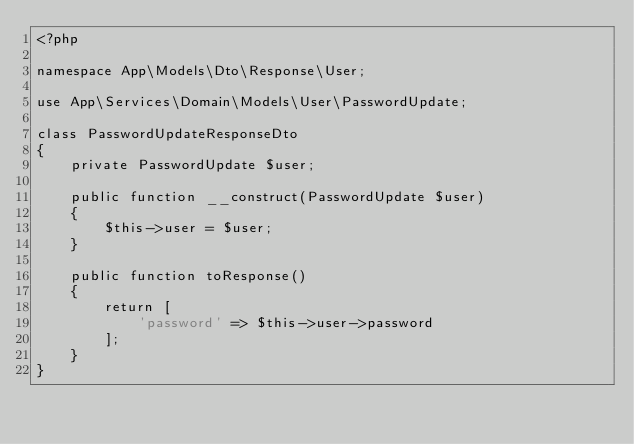<code> <loc_0><loc_0><loc_500><loc_500><_PHP_><?php

namespace App\Models\Dto\Response\User;

use App\Services\Domain\Models\User\PasswordUpdate;

class PasswordUpdateResponseDto
{
    private PasswordUpdate $user;

    public function __construct(PasswordUpdate $user)
    {
        $this->user = $user;
    }

    public function toResponse()
    {
        return [
            'password' => $this->user->password
        ];
    }
}
</code> 